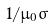Convert formula to latex. <formula><loc_0><loc_0><loc_500><loc_500>1 / \mu _ { 0 } \sigma</formula> 